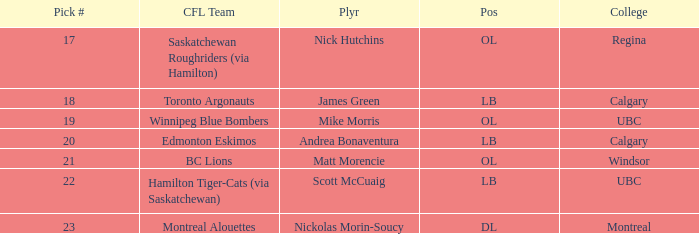What position is the player who went to Regina?  OL. 